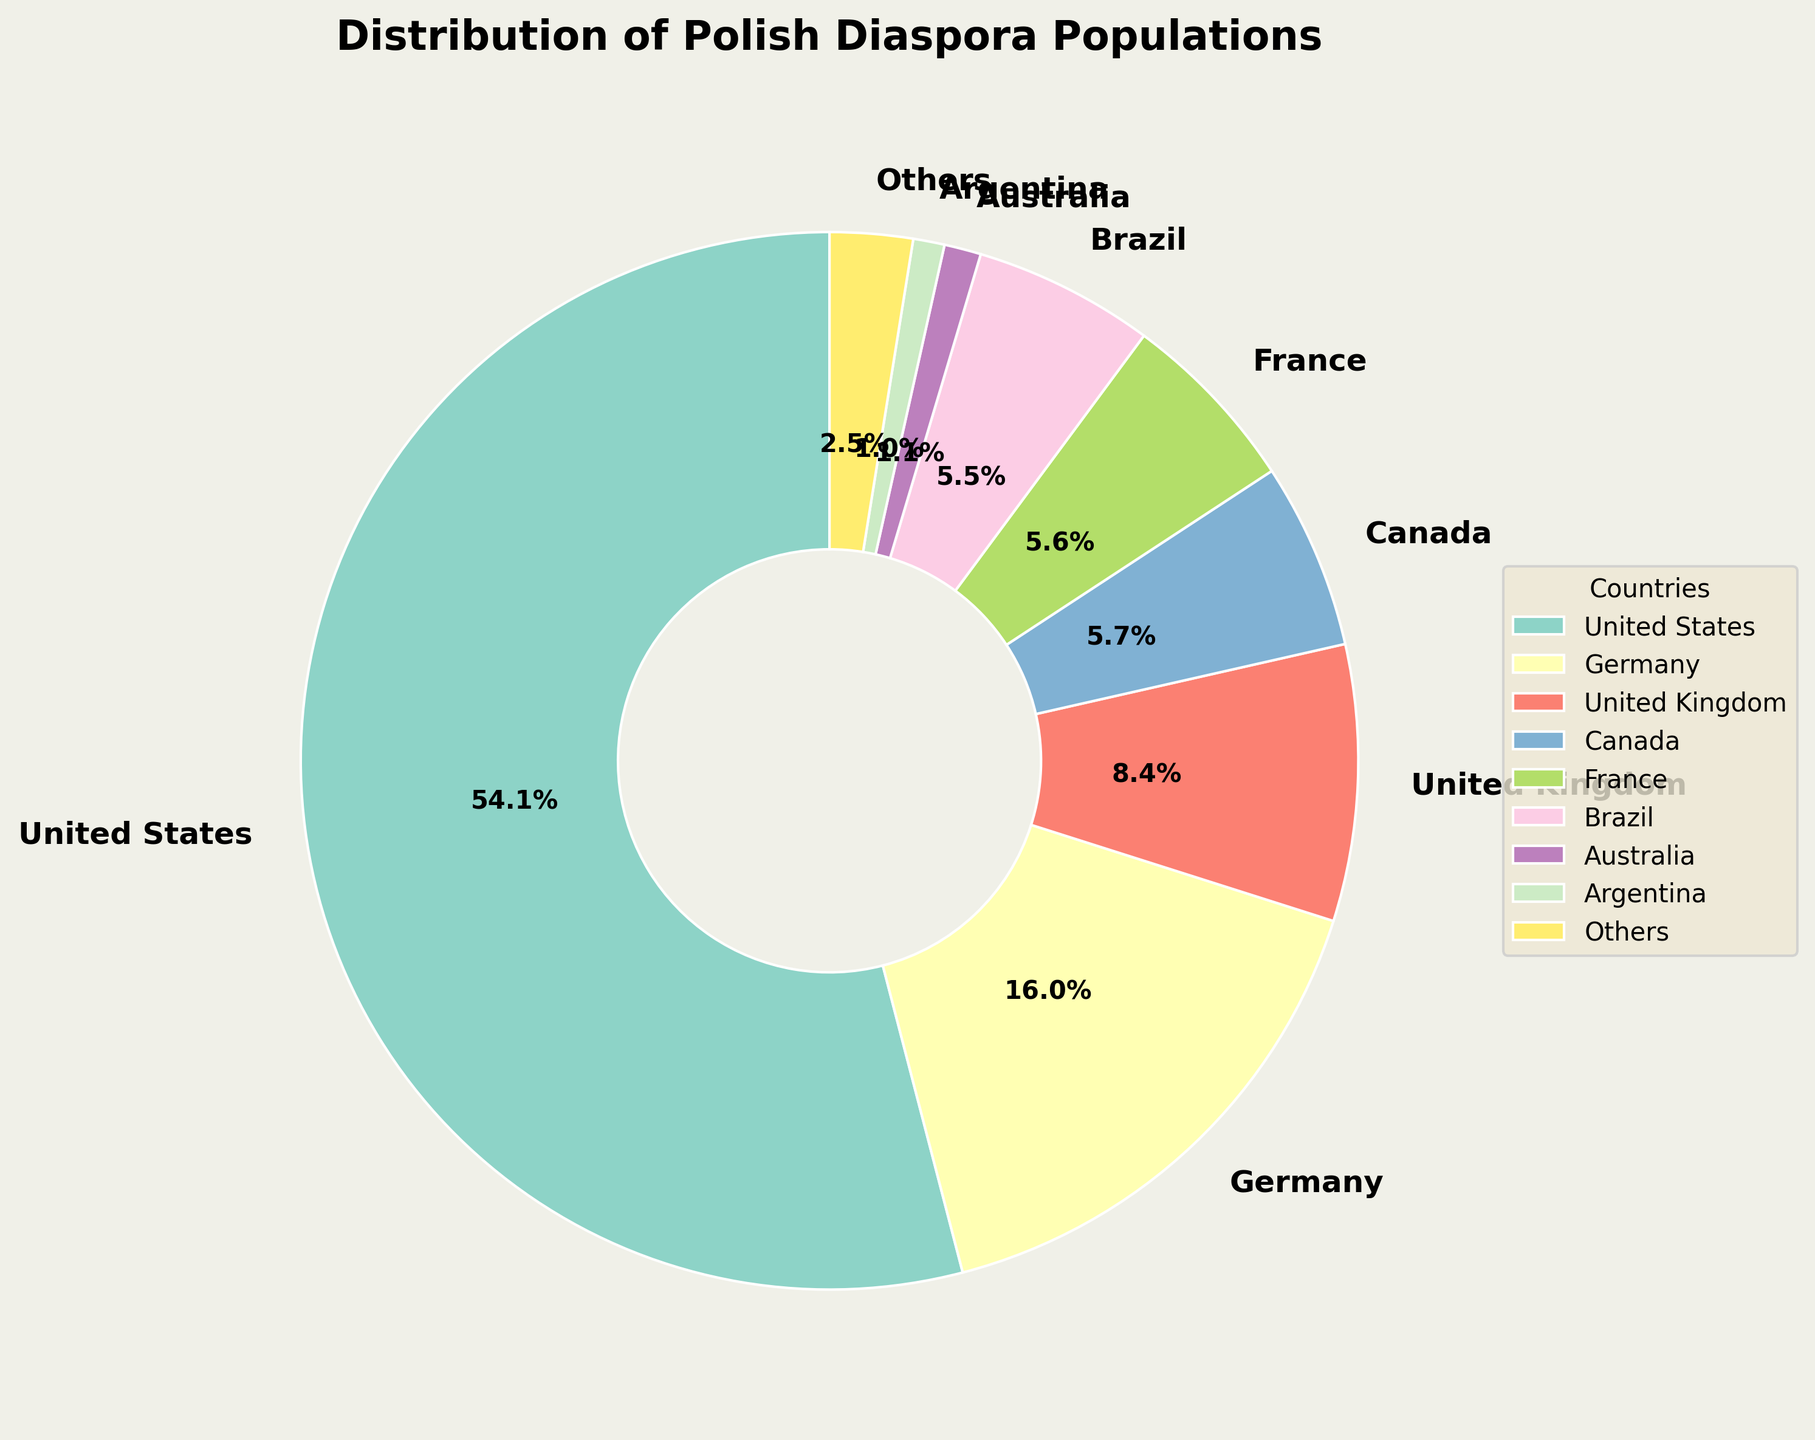Which country has the largest Polish diaspora population? The pie chart shows the distribution, and the largest segment represents the United States.
Answer: United States What's the combined percentage of the Polish diaspora in Canada and Germany? From the chart, Canada's population percentage is 5.9% and Germany's is 16.7%. Add these percentages together: 5.9% + 16.7% = 22.6%.
Answer: 22.6% Which country, among the top 8, has the smallest percentage of the Polish diaspora population? From the portions of the pie chart representing the top 8 countries, Australia has the smallest segment.
Answer: Australia How does the Polish diaspora in the United Kingdom compare to that in Brazil? The pie chart shows the United Kingdom has a percentage that is larger than that of Brazil. Compare the percentages directly: the UK is 8.8% and Brazil is 5.7%.
Answer: United Kingdom has a larger percentage What is the total percentage contribution of the countries listed as 'Others'? 'Others' combines all countries beyond the top 8 listed in the pie chart. The chart shows that 'Others' segment is 2.4%.
Answer: 2.4% If you were to combine the populations from the United States and Brazil, what percentage of the total Polish diaspora would that be? From the pie chart, the United States has 56.3% and Brazil has 5.7%, summing up these: 56.3% + 5.7% = 62%.
Answer: 62% How much larger is the Polish diaspora in France compared to Norway in percentage terms? France's percentage segment on the pie chart is 5.9% while Norway is part of 'Others' and contributes much less. Calculate the difference: 5.9% - (percentage in 'Others' which is 2.4% combined). Since specific Norway's percentage is not given in 'Others', it can be inferred France is much larger in comparison.
Answer: Significantly larger What is the difference in percentage points between the Polish diaspora populations in Germany and the United Kingdom? The pie chart indicates Germany at 16.7% and the United Kingdom at 8.8%. The difference is calculated as 16.7% - 8.8% = 7.9%.
Answer: 7.9% Which color segment represents Canada in the pie chart? Looking at the labeled segments and corresponding colors, Canada is represented with a specific color. Observe the legend or chart labels for the exact color.
Answer: (Answer depends on the visual chart, eg. pale green) 